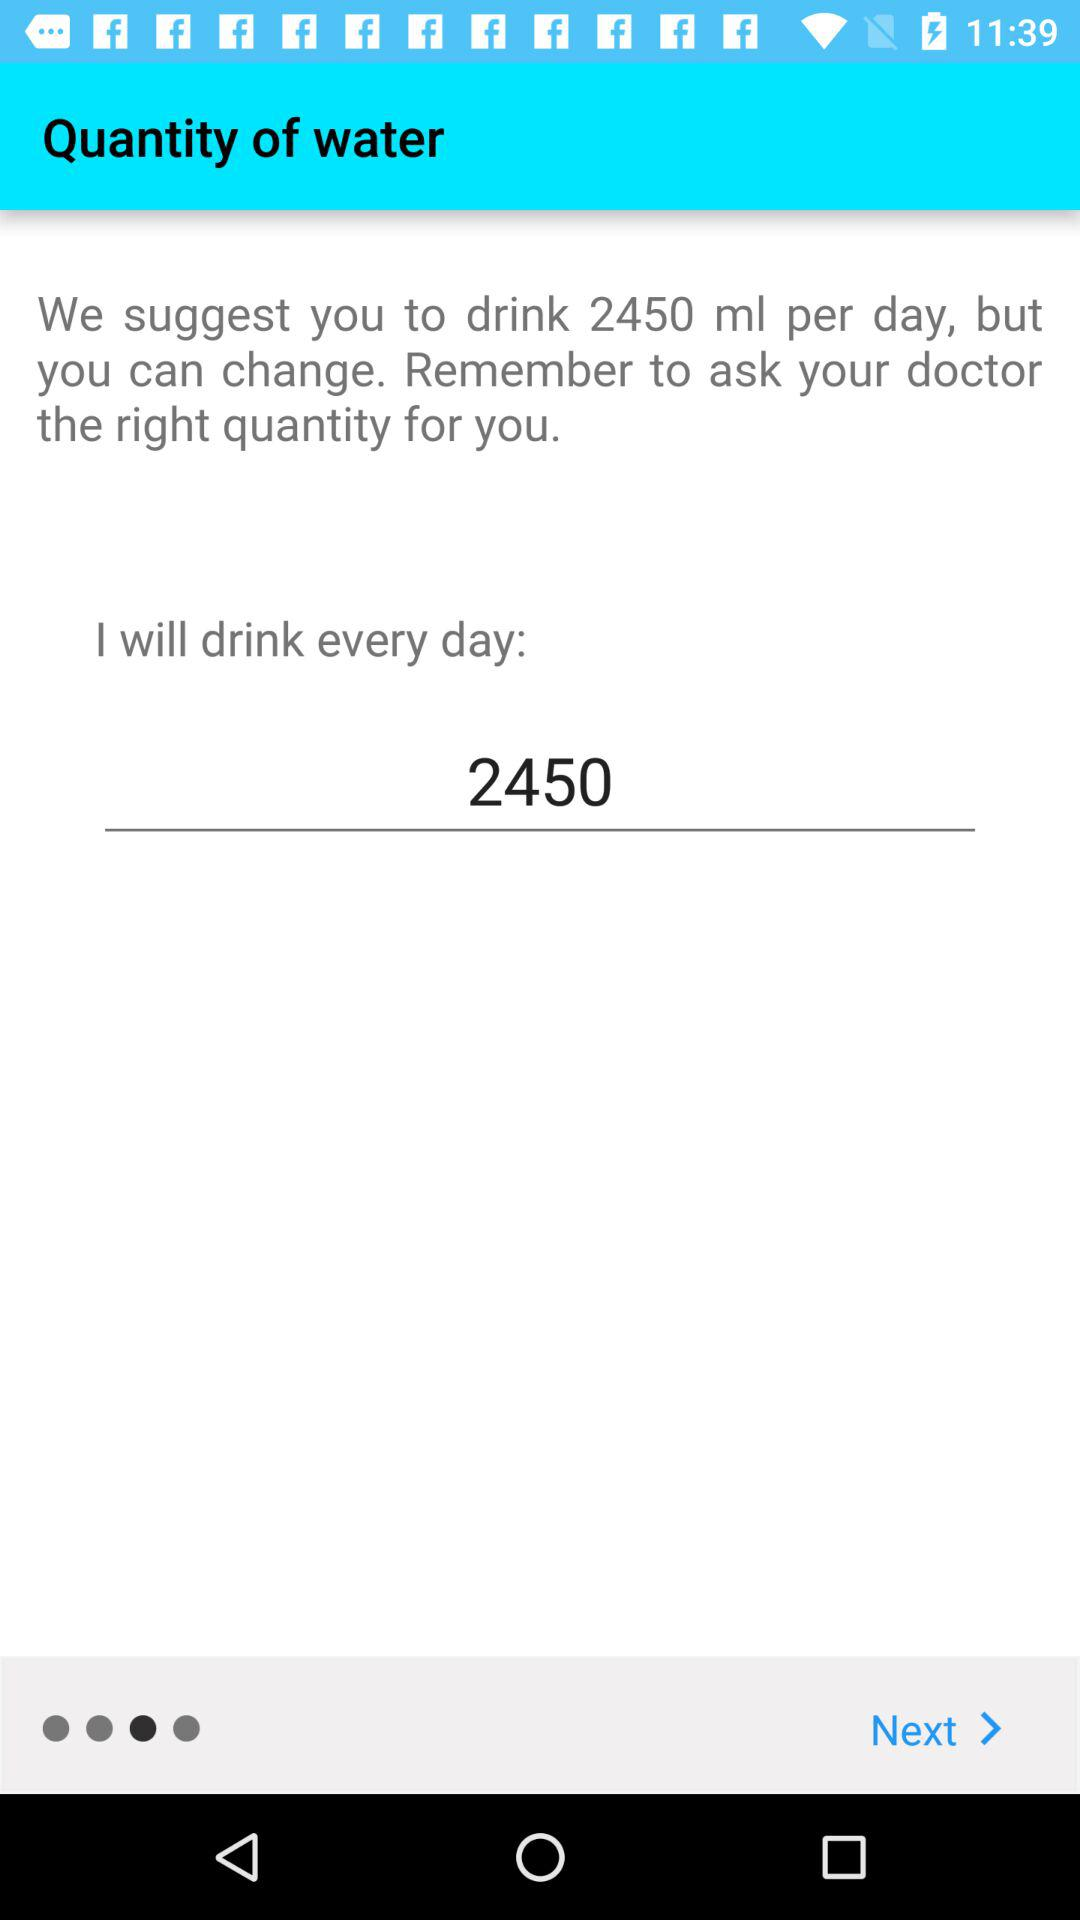How many milliliters of water should I drink every day?
Answer the question using a single word or phrase. 2450 